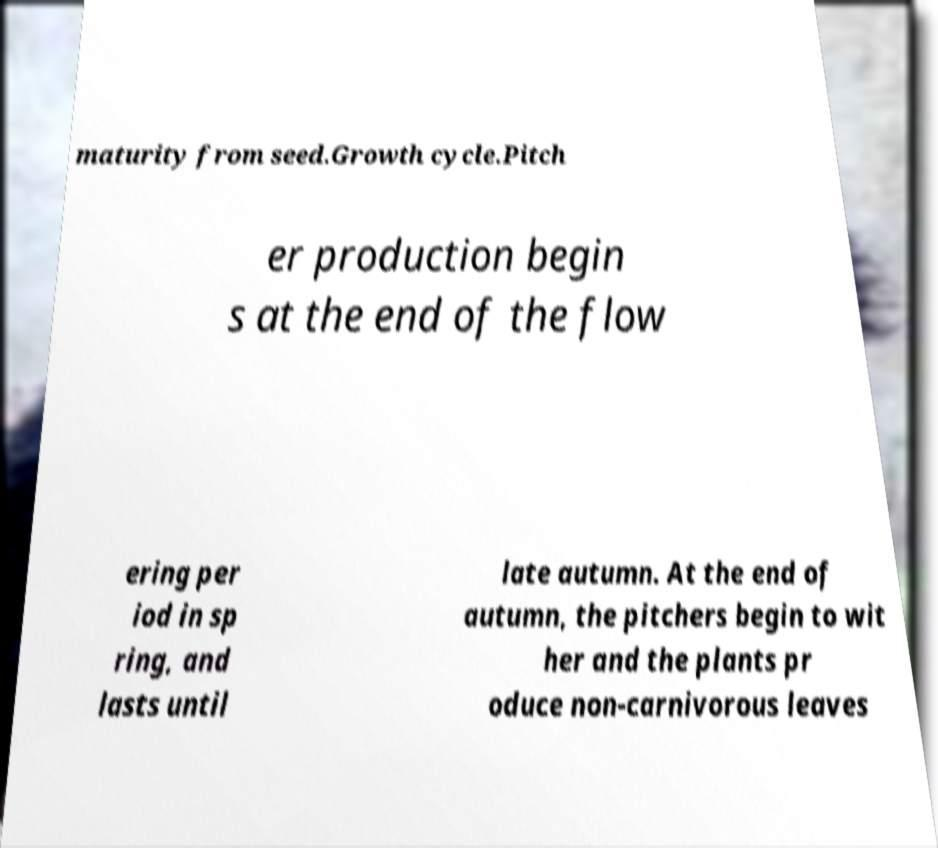What messages or text are displayed in this image? I need them in a readable, typed format. maturity from seed.Growth cycle.Pitch er production begin s at the end of the flow ering per iod in sp ring, and lasts until late autumn. At the end of autumn, the pitchers begin to wit her and the plants pr oduce non-carnivorous leaves 